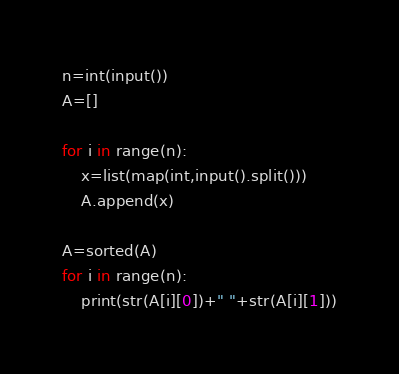<code> <loc_0><loc_0><loc_500><loc_500><_Python_>n=int(input())
A=[]

for i in range(n):
    x=list(map(int,input().split()))
    A.append(x)

A=sorted(A)
for i in range(n):
    print(str(A[i][0])+" "+str(A[i][1]))

</code> 